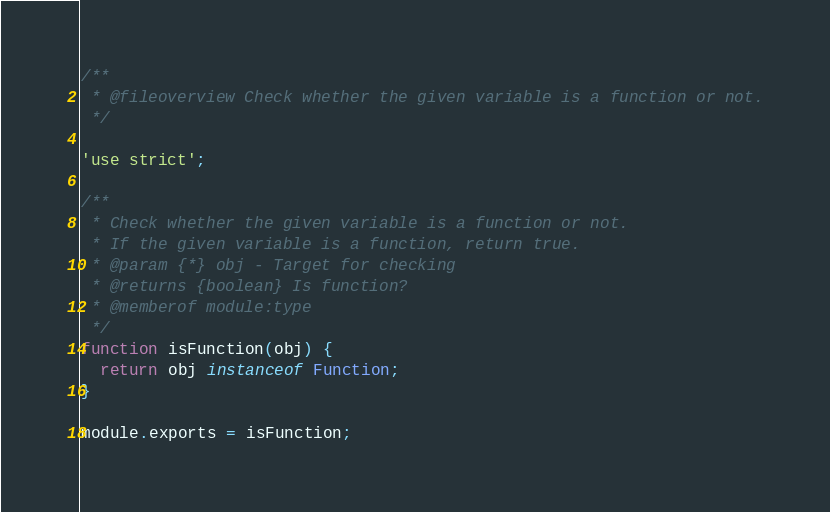Convert code to text. <code><loc_0><loc_0><loc_500><loc_500><_JavaScript_>/**
 * @fileoverview Check whether the given variable is a function or not.
 */

'use strict';

/**
 * Check whether the given variable is a function or not.
 * If the given variable is a function, return true.
 * @param {*} obj - Target for checking
 * @returns {boolean} Is function?
 * @memberof module:type
 */
function isFunction(obj) {
  return obj instanceof Function;
}

module.exports = isFunction;
</code> 